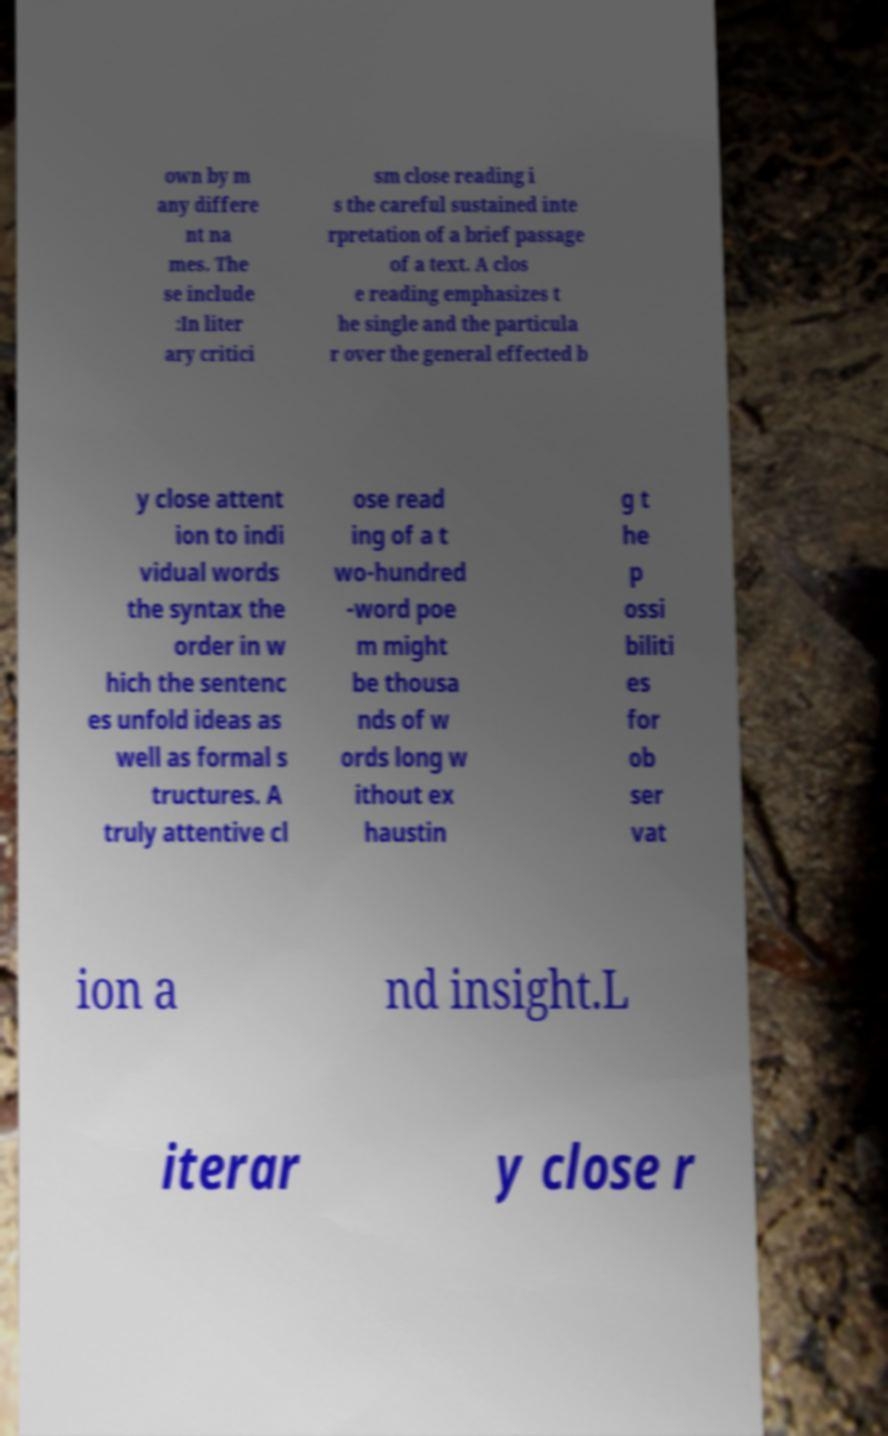For documentation purposes, I need the text within this image transcribed. Could you provide that? own by m any differe nt na mes. The se include :In liter ary critici sm close reading i s the careful sustained inte rpretation of a brief passage of a text. A clos e reading emphasizes t he single and the particula r over the general effected b y close attent ion to indi vidual words the syntax the order in w hich the sentenc es unfold ideas as well as formal s tructures. A truly attentive cl ose read ing of a t wo-hundred -word poe m might be thousa nds of w ords long w ithout ex haustin g t he p ossi biliti es for ob ser vat ion a nd insight.L iterar y close r 